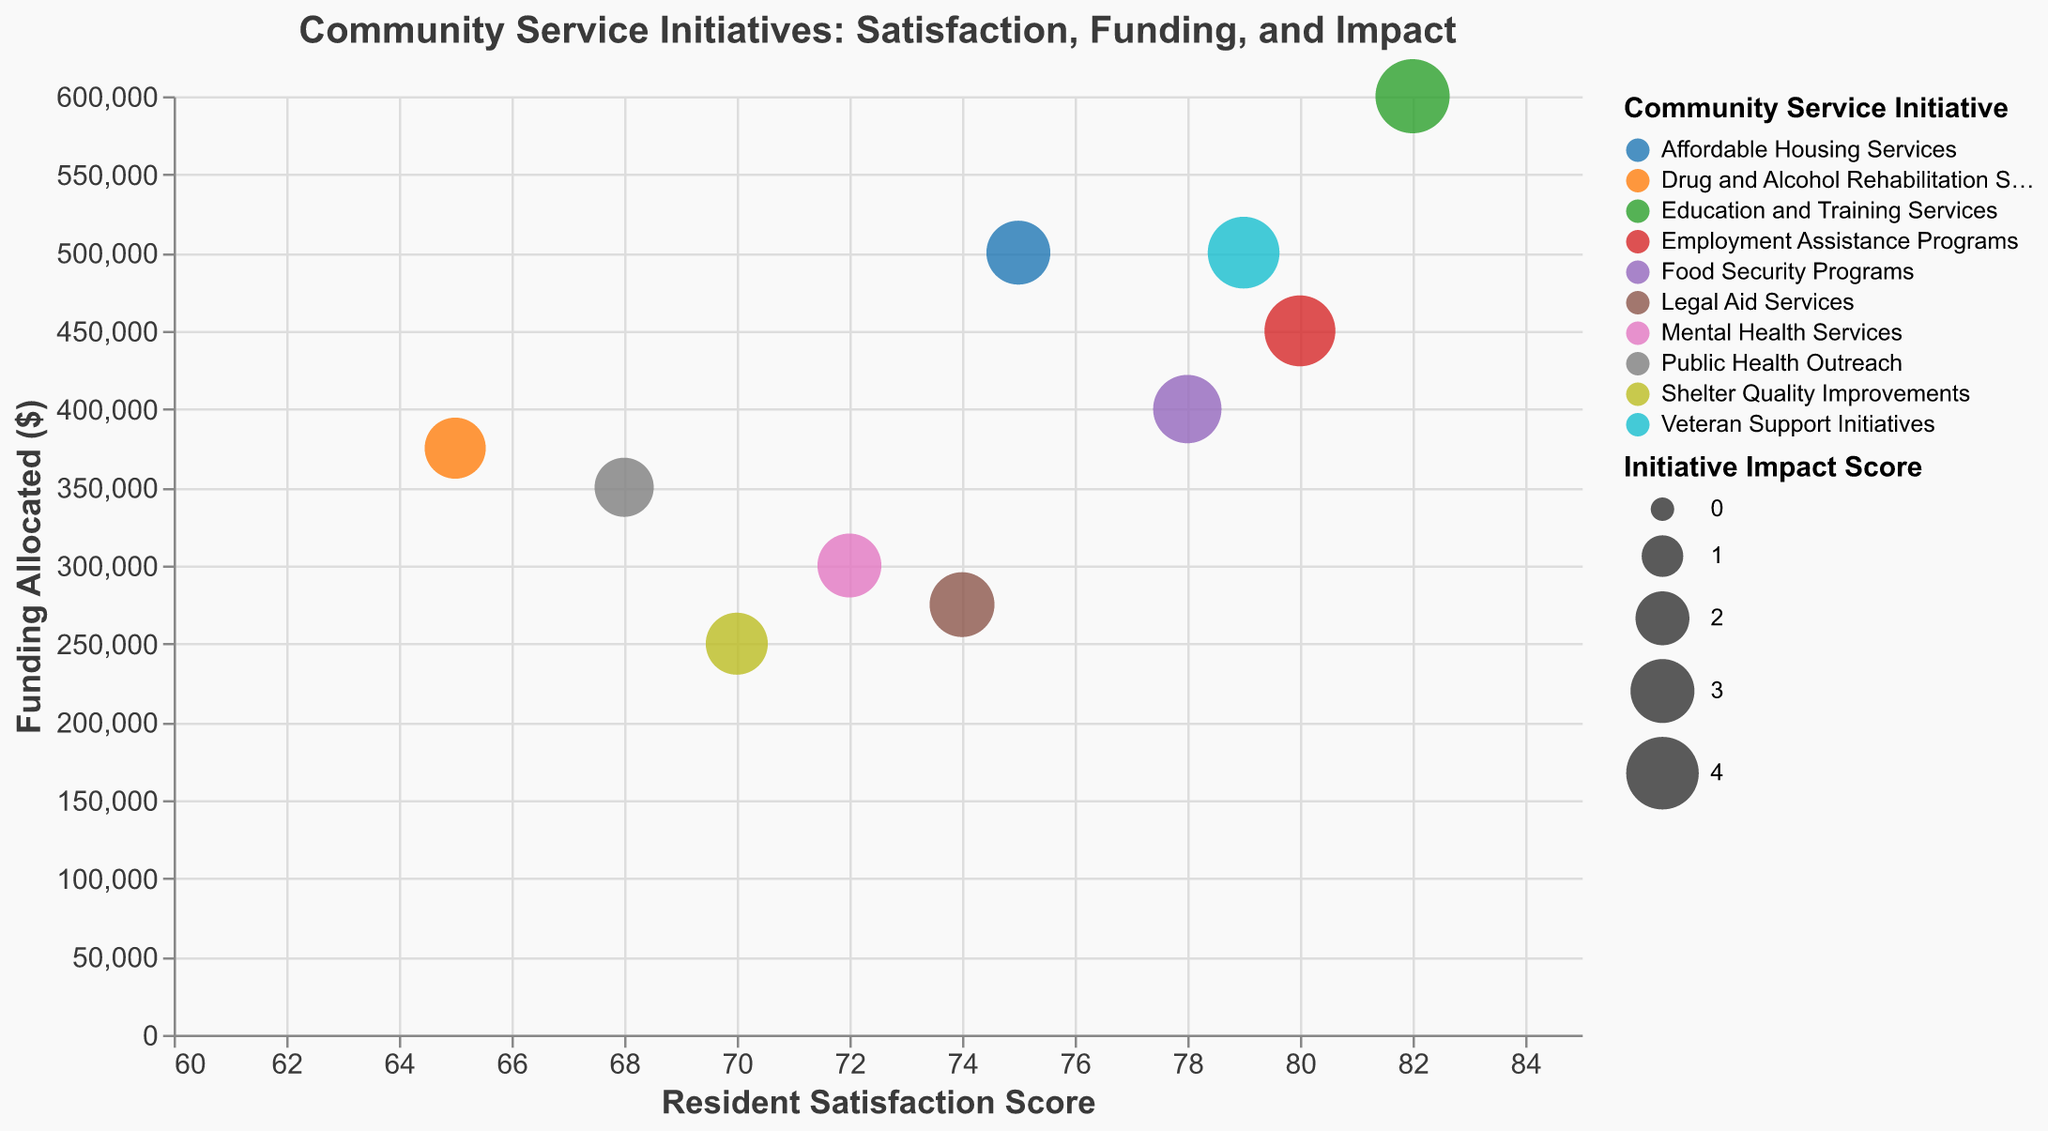What is the initiative with the highest Resident Satisfaction Score? Look for the initiative with the highest value on the x-axis, which represents the Resident Satisfaction Score.
Answer: Education and Training Services Which initiative received the least funding? Locate the initiative with the lowest value on the y-axis, which represents the Funding Allocated.
Answer: Shelter Quality Improvements What is the initiative with the highest impact score? Check the legend and tooltip information for the largest bubble, which corresponds to the highest Initiative Impact Score.
Answer: Education and Training Services How many initiatives have a Resident Satisfaction Score of over 75? Count all data points (bubbles) positioned on the x-axis above the value of 75.
Answer: 5 Which initiative has the highest ratio of Resident Satisfaction Score to Funding Allocated? Calculate the ratio of Resident Satisfaction Score to Funding Allocated for all initiatives and determine the highest value. For example, 75/500000 for Affordable Housing Services.
Answer: Education and Training Services What is the overall trend observed between Resident Satisfaction Score and Funding Allocated? Estimate whether the relationship between the x-axis (Resident Satisfaction Score) and y-axis (Funding Allocated) is positive, negative, or has no clear trend by visually inspecting the direction of the bubbles.
Answer: No clear trend Which two initiatives have the closest Resident Satisfaction Scores but very different Funding Allocated? Identify pairs of data points that are close to each other horizontally but diverge significantly vertically, such as comparing their Resident Satisfaction Scores and differences in Funding Allocated.
Answer: Affordable Housing Services and Legal Aid Services What is the total Funding Allocated for initiatives with an Initiative Impact Score over 3? Sum the Funding Allocated values for all initiatives with an Initiative Impact Score greater than 3. This includes Employment Assistance Programs, Food Security Programs, Education and Training Services, and Veteran Support Initiatives. Calculation: 450000 + 400000 + 600000 + 500000.
Answer: $1,950,000 